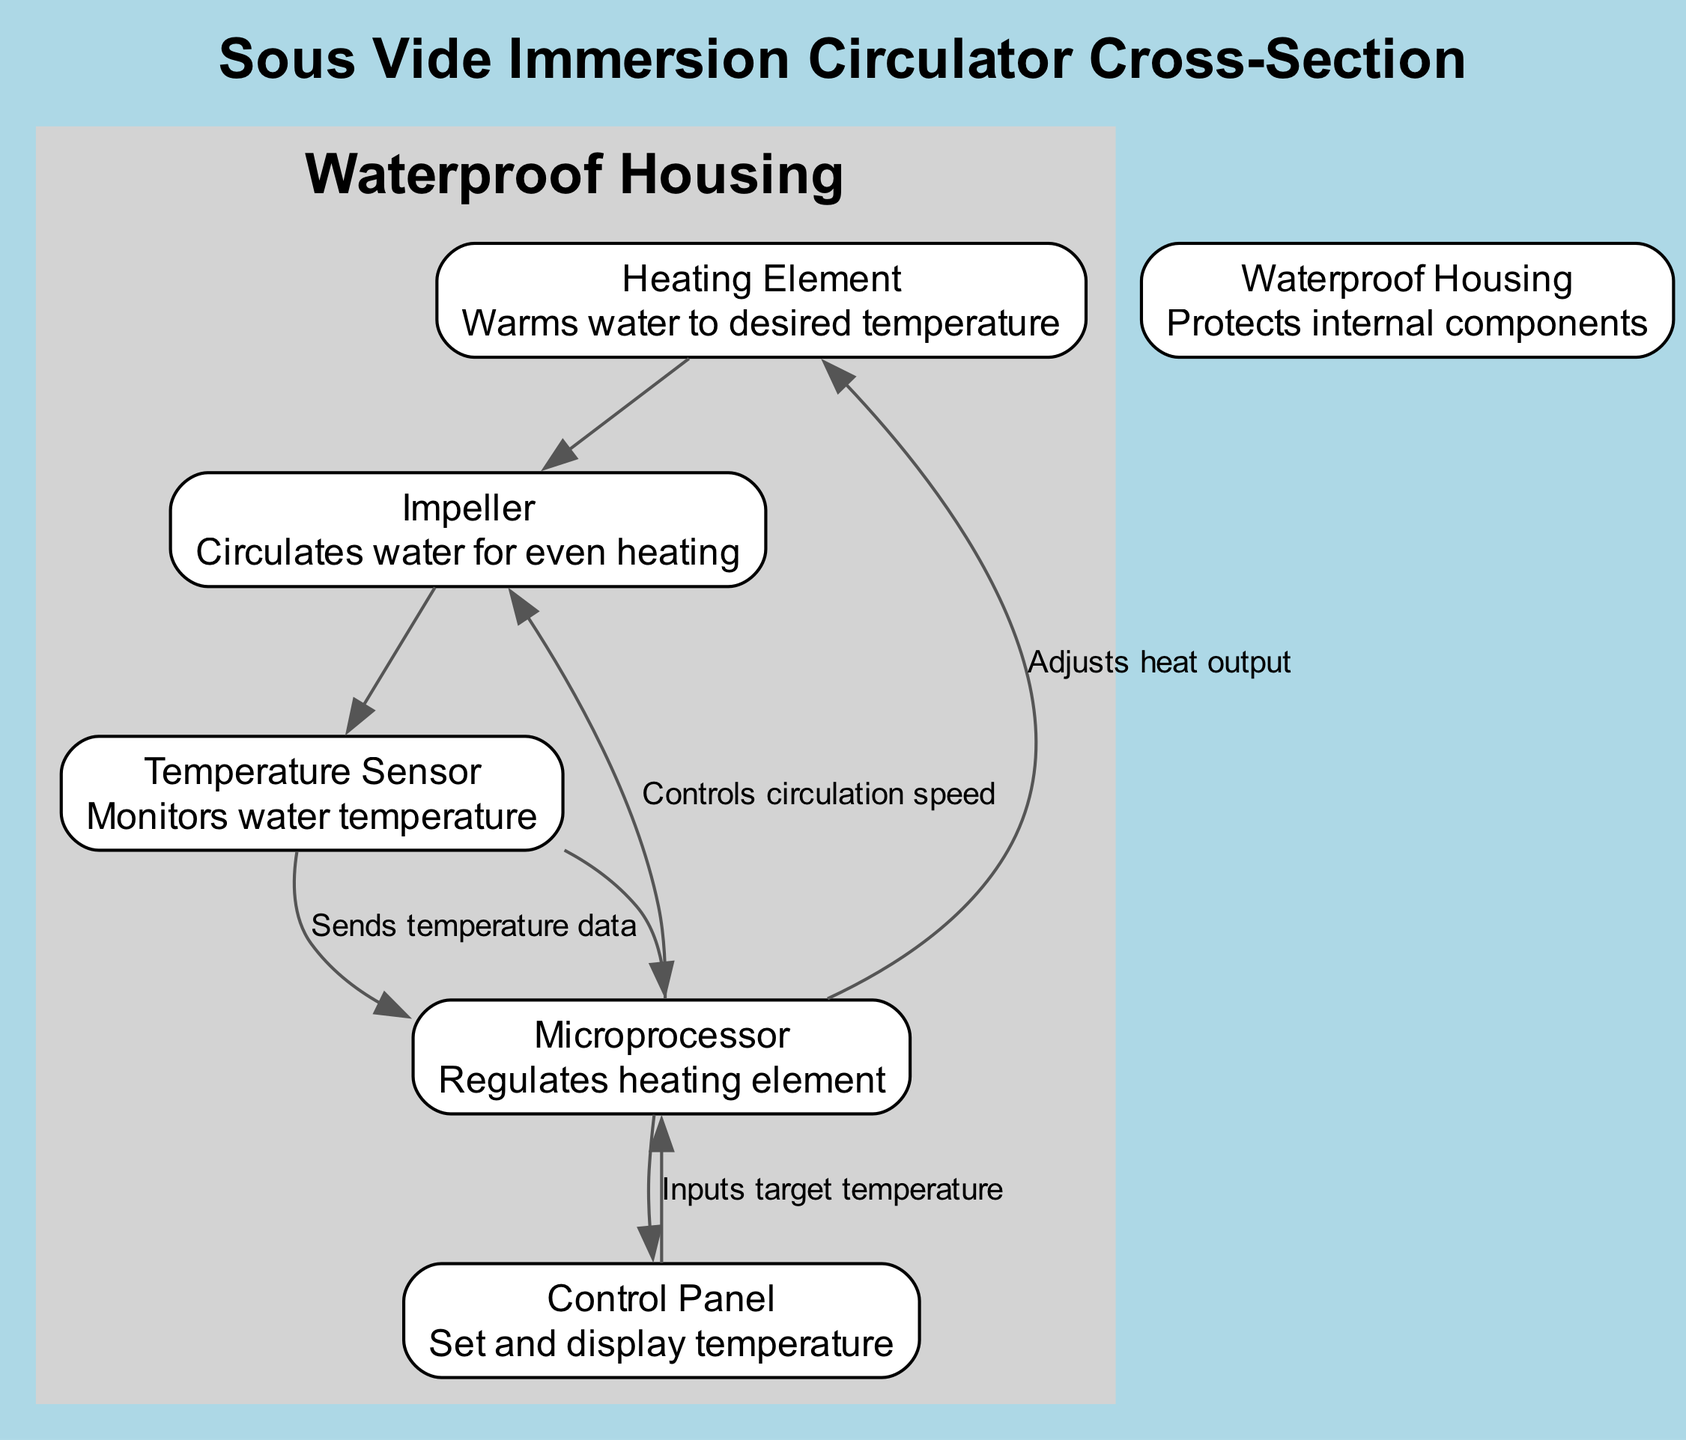What is the function of the heating element? According to the diagram, the heating element is responsible for warming the water to the desired temperature. This is indicated in its description.
Answer: Warms water to desired temperature How many nodes are in the diagram? The diagram includes a total of six nodes, as listed in the node section of the data provided.
Answer: 6 What does the temperature sensor send data to? The diagram shows that the temperature sensor sends temperature data to the microprocessor, which regulates the overall heating mechanism in the device.
Answer: Microprocessor What controls the circulation speed? According to the flow indicated in the diagram, the microprocessor is responsible for controlling the speed of the impeller. This implies a direct relationship between the microprocessor and the impeller for water circulation.
Answer: Impeller What inputs the target temperature to the microprocessor? The flow in the diagram shows that the control panel sends the target temperature to the microprocessor, which uses this information to adjust heating.
Answer: Control Panel What is the main protective component of the immersion circulator? The waterproof housing is specifically designed to protect all internal components from water damage, as stated in its description in the diagram.
Answer: Waterproof Housing How does the microprocessor adjust heat output? The microprocessor adjusts heat output based on the temperature data it receives from the temperature sensor, thus controlling the heating element in response to current water conditions.
Answer: Heating Element What type of diagram is this? This diagram is identified as a natural science diagram, specifically illustrating the internal structure and functioning of a sous vide immersion circulator.
Answer: Natural Science Diagram 